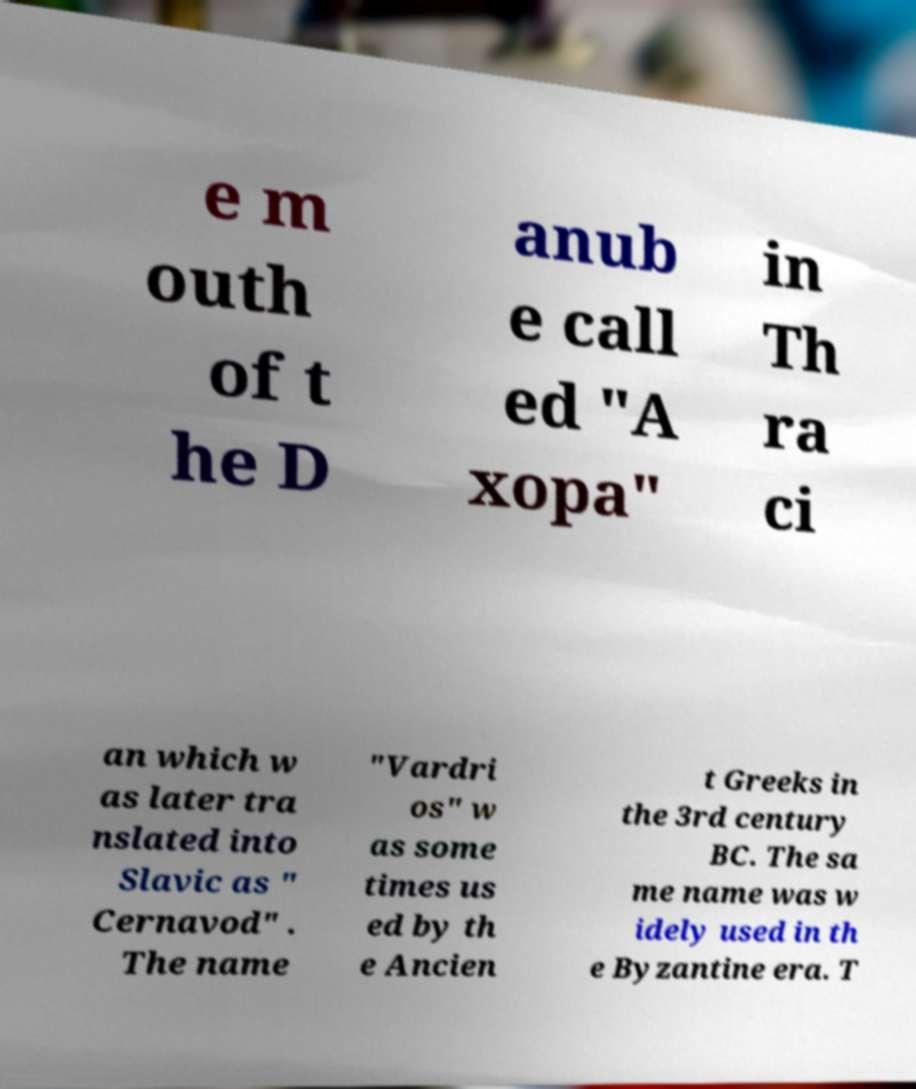Can you read and provide the text displayed in the image?This photo seems to have some interesting text. Can you extract and type it out for me? e m outh of t he D anub e call ed "A xopa" in Th ra ci an which w as later tra nslated into Slavic as " Cernavod" . The name "Vardri os" w as some times us ed by th e Ancien t Greeks in the 3rd century BC. The sa me name was w idely used in th e Byzantine era. T 